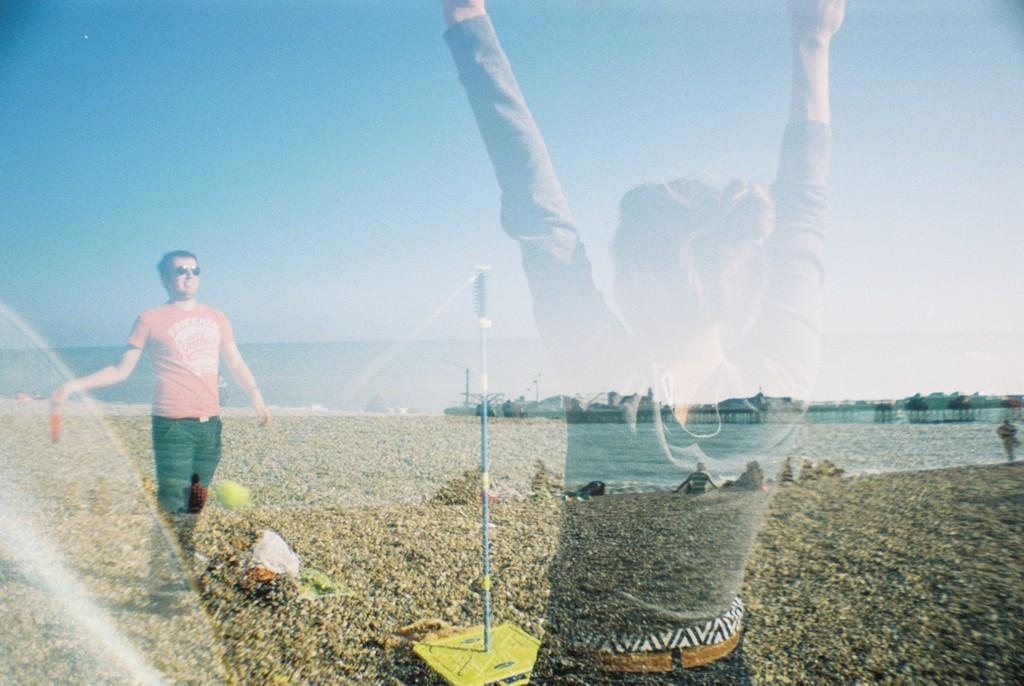What is the position of the man in the image? The man is standing on the left side of the image. Who is located in the center of the image? There is a lady in the center of the image. What can be seen in the background of the image? There is a sea, a pole, and sheds visible in the background of the image. What is visible at the top of the image? The sky is visible at the top of the image. How many minutes does it take for the duck to swim across the sea in the image? There is no duck present in the image, so it is not possible to determine how long it would take for a duck to swim across the sea. 